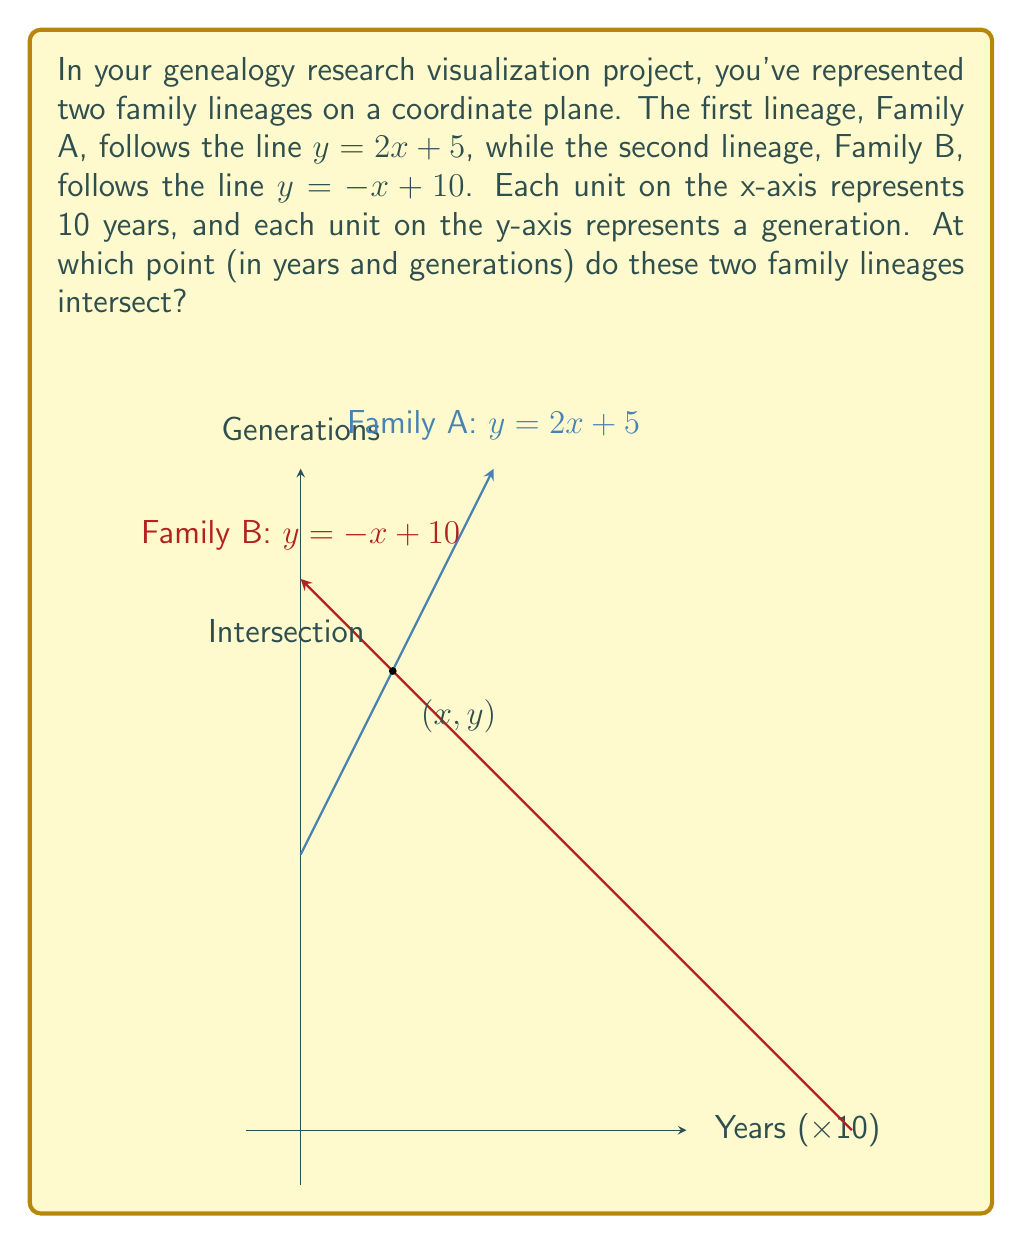Provide a solution to this math problem. To find the intersection point of the two family lineages, we need to solve the system of equations:

$$\begin{cases}
y = 2x + 5 \quad \text{(Family A)}\\
y = -x + 10 \quad \text{(Family B)}
\end{cases}$$

Step 1: Set the equations equal to each other since they intersect at the same point.
$2x + 5 = -x + 10$

Step 2: Solve for x by adding x to both sides and subtracting 5 from both sides.
$3x = 5$
$x = \frac{5}{3}$

Step 3: Substitute this x-value into either equation to find y. Let's use Family A's equation:
$y = 2(\frac{5}{3}) + 5$
$y = \frac{10}{3} + 5$
$y = \frac{10}{3} + \frac{15}{3} = \frac{25}{3}$

Step 4: Interpret the results:
- x-coordinate: $\frac{5}{3} \times 10 = 16.67$ years (rounded to two decimal places)
- y-coordinate: $\frac{25}{3} \approx 8.33$ generations (rounded to two decimal places)

Therefore, the two family lineages intersect at approximately 16.67 years (on the x-axis) and 8.33 generations (on the y-axis).
Answer: $(16.67, 8.33)$ 